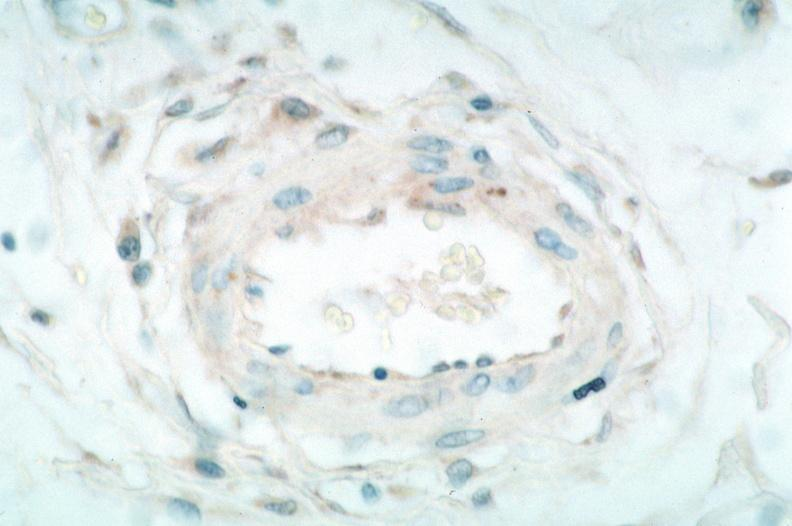s carcinoma spotted fever, immunoperoxidase staining vessels for rickettsia rickettsii?
Answer the question using a single word or phrase. No 